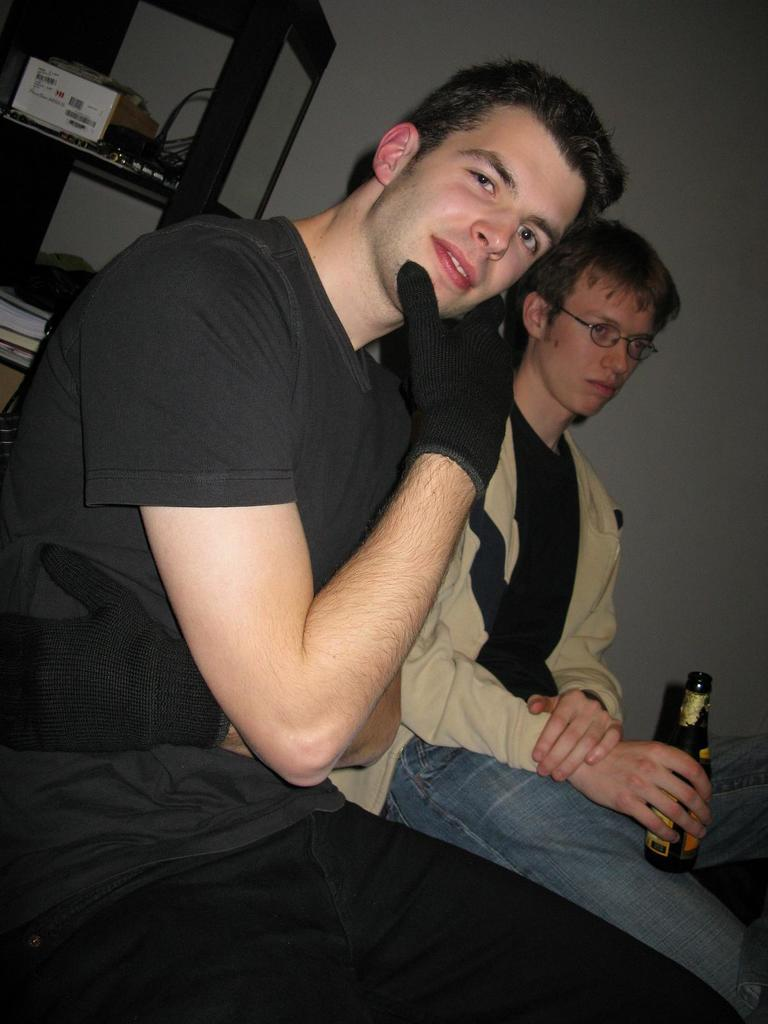How many people are in the image? There are two men in the image. What are the men doing in the image? The men are sitting. What is one of the men holding in his hand? One man is holding a bottle in his hand. What can be seen in the background of the image? There is a rack with items on it and a wall visible in the background of the image. What type of chalk is being used to draw on the wall in the image? There is no chalk or drawing on the wall present in the image. What was the afterthought that led to the addition of the items on the rack in the image? There is no information provided about the reason for the items on the rack, so we cannot determine any afterthought that led to their presence. 